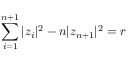<formula> <loc_0><loc_0><loc_500><loc_500>\sum _ { i = 1 } ^ { n + 1 } | z _ { i } | ^ { 2 } - n | z _ { n + 1 } | ^ { 2 } = r</formula> 